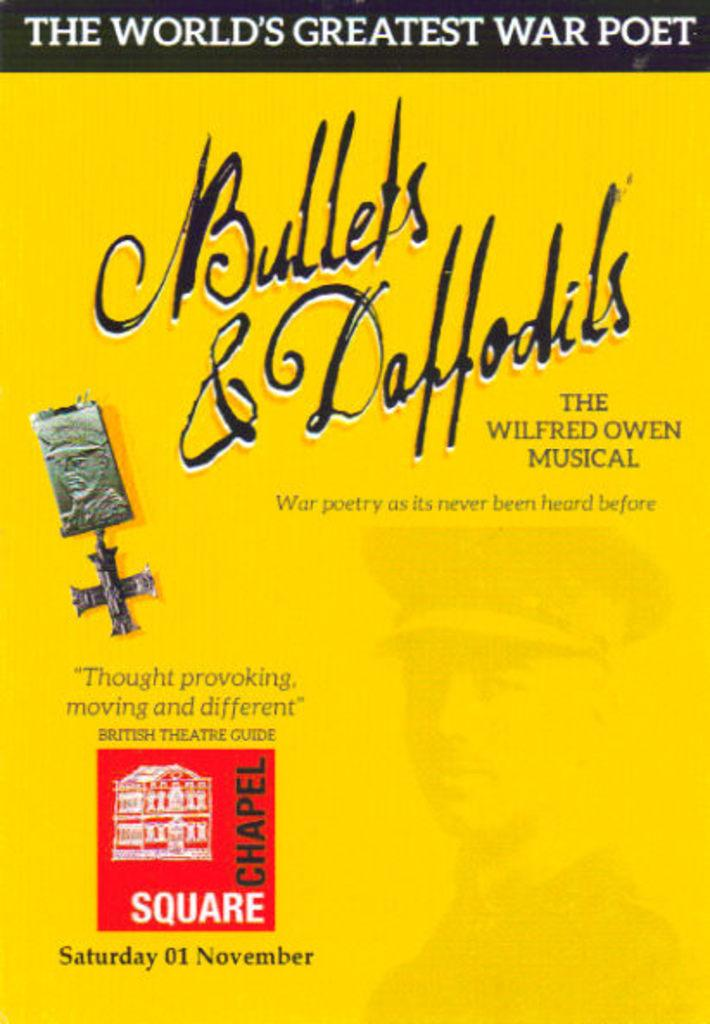<image>
Present a compact description of the photo's key features. a yellow book with the word bullets on it 